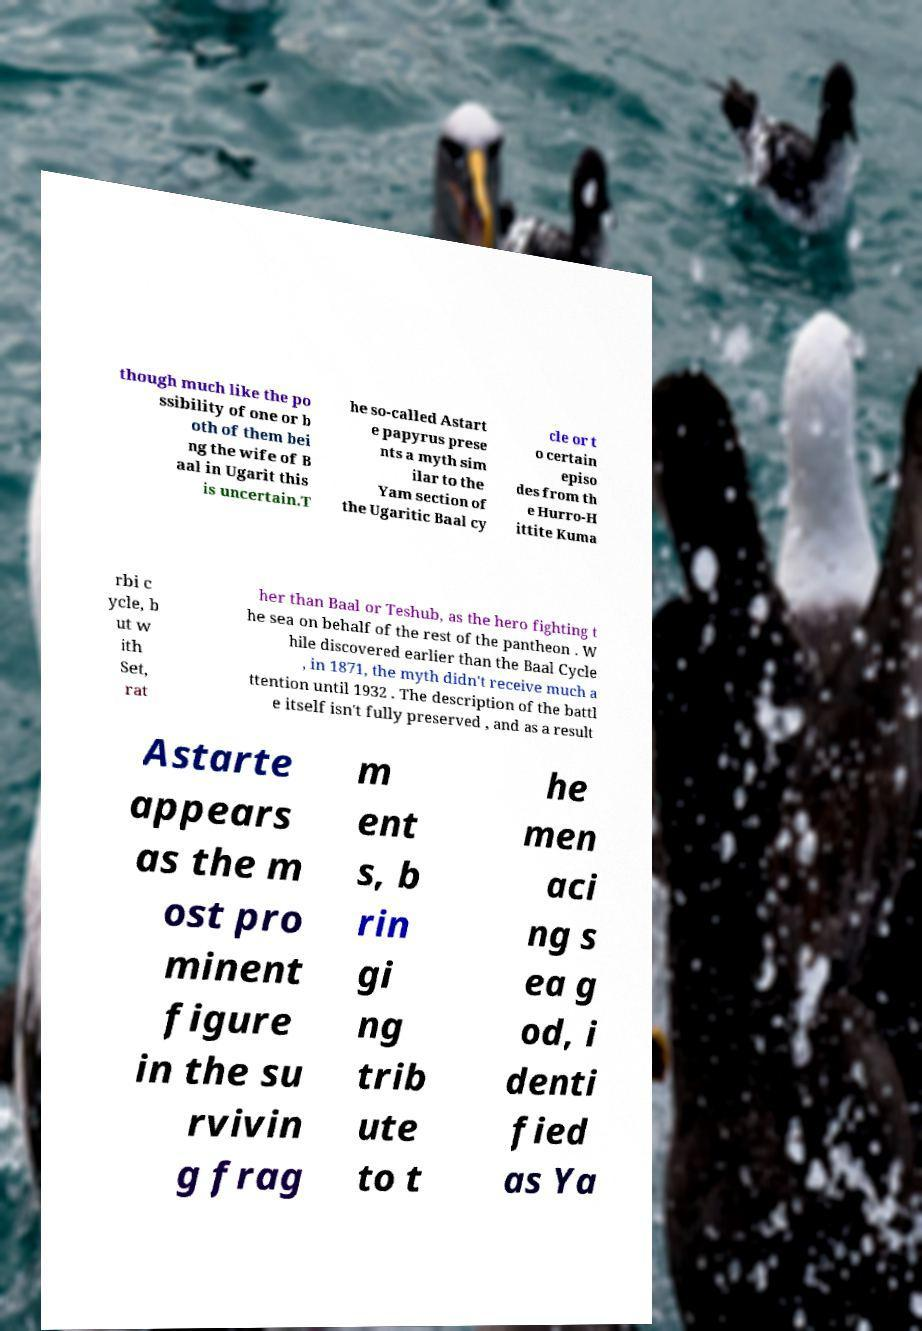Please read and relay the text visible in this image. What does it say? though much like the po ssibility of one or b oth of them bei ng the wife of B aal in Ugarit this is uncertain.T he so-called Astart e papyrus prese nts a myth sim ilar to the Yam section of the Ugaritic Baal cy cle or t o certain episo des from th e Hurro-H ittite Kuma rbi c ycle, b ut w ith Set, rat her than Baal or Teshub, as the hero fighting t he sea on behalf of the rest of the pantheon . W hile discovered earlier than the Baal Cycle , in 1871, the myth didn't receive much a ttention until 1932 . The description of the battl e itself isn't fully preserved , and as a result Astarte appears as the m ost pro minent figure in the su rvivin g frag m ent s, b rin gi ng trib ute to t he men aci ng s ea g od, i denti fied as Ya 